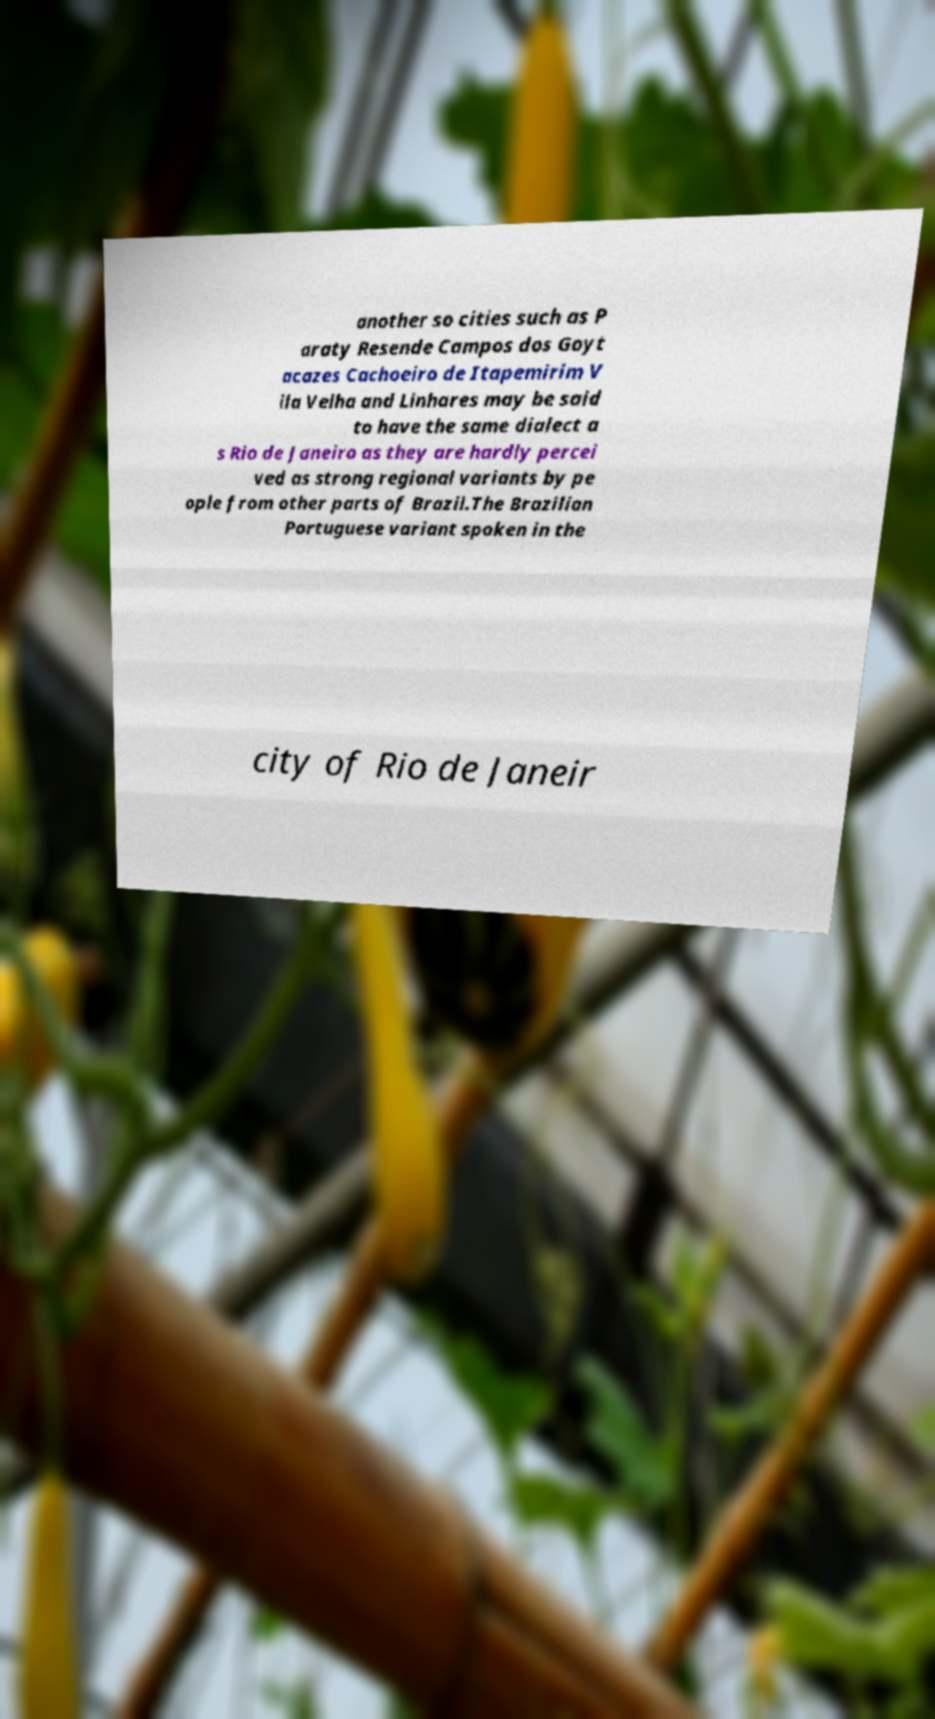I need the written content from this picture converted into text. Can you do that? another so cities such as P araty Resende Campos dos Goyt acazes Cachoeiro de Itapemirim V ila Velha and Linhares may be said to have the same dialect a s Rio de Janeiro as they are hardly percei ved as strong regional variants by pe ople from other parts of Brazil.The Brazilian Portuguese variant spoken in the city of Rio de Janeir 